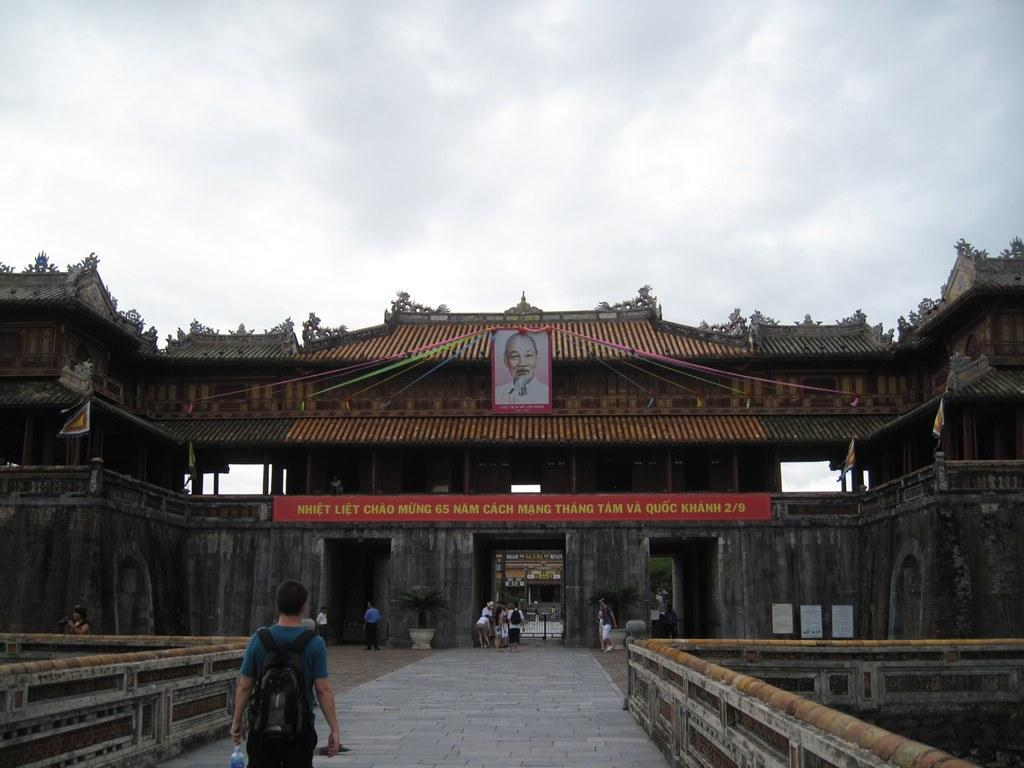What is the main subject of the image? There is a person walking on a path in the image. What can be seen in the background of the image? There is a building, a photograph, a group of persons, and the sky visible in the background of the image. What is the condition of the sky in the image? The sky is visible in the background of the image, and there are clouds present. Reasoning: Let' Let's think step by step in order to produce the conversation. We start by identifying the main subject of the image, which is the person walking on the path. Then, we describe the background of the image, including the building, photograph, group of persons, and sky. Finally, we focus on the sky's condition, mentioning the presence of clouds. Absurd Question/Question/Answer: How many pizzas are being delivered by the laborer in the image? There is no laborer or pizza present in the image. What type of house is visible in the background of the image? There is no house visible in the background of the image; only a building is present. 